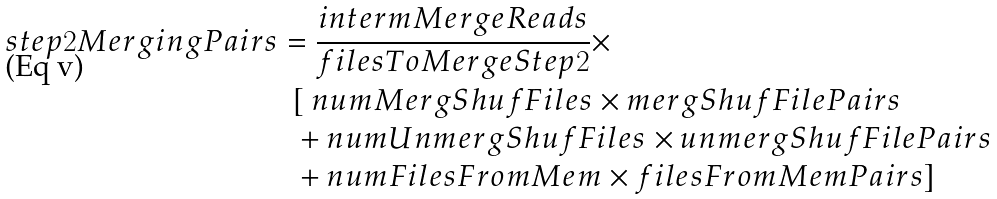Convert formula to latex. <formula><loc_0><loc_0><loc_500><loc_500>s t e p 2 M e r g i n g P a i r s & = \frac { i n t e r m M e r g e R e a d s } { f i l e s T o M e r g e S t e p 2 } \times \\ & \ \ [ \ n u m M e r g S h u f F i l e s \times m e r g S h u f F i l e P a i r s \\ & \ \ + n u m U n m e r g S h u f F i l e s \times u n m e r g S h u f F i l e P a i r s \\ & \ \ + n u m F i l e s F r o m M e m \times f i l e s F r o m M e m P a i r s ]</formula> 